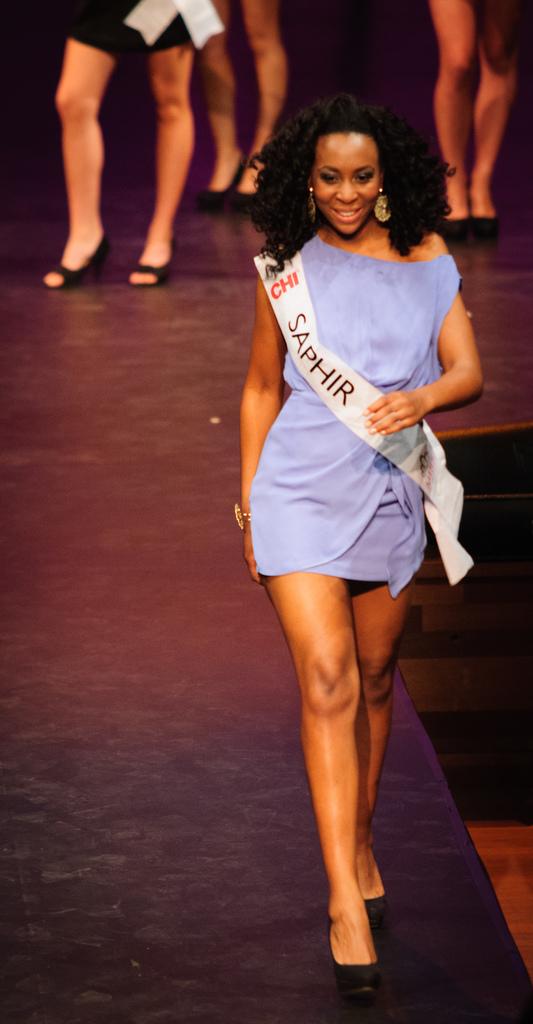What is on the woman's sash?
Ensure brevity in your answer.  Saphir. What does her sash say?
Make the answer very short. Saphir. 